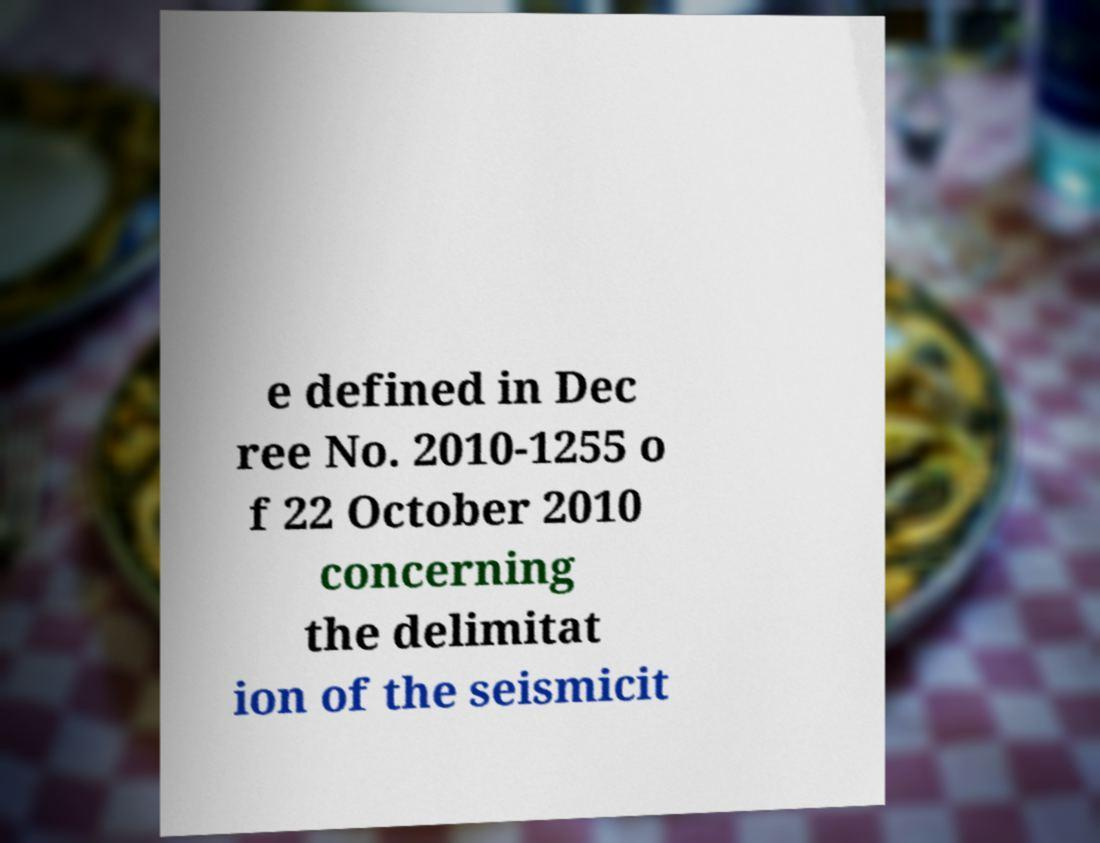Please identify and transcribe the text found in this image. e defined in Dec ree No. 2010-1255 o f 22 October 2010 concerning the delimitat ion of the seismicit 